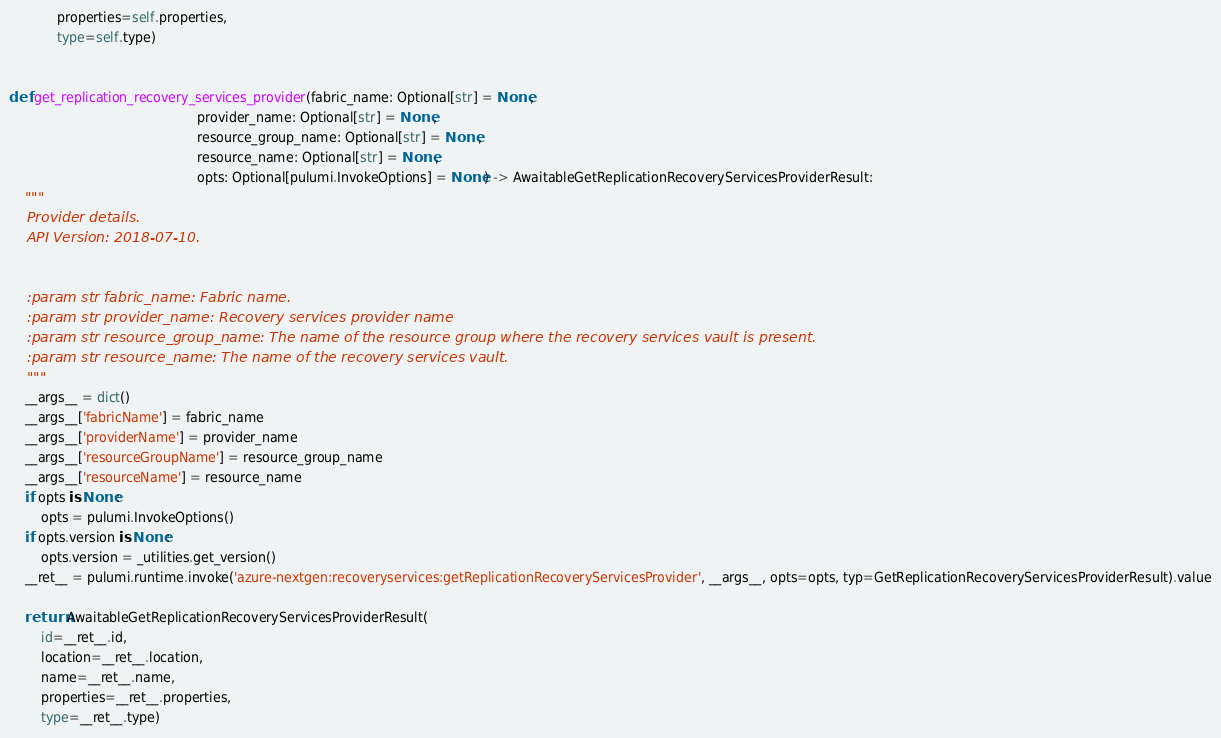Convert code to text. <code><loc_0><loc_0><loc_500><loc_500><_Python_>            properties=self.properties,
            type=self.type)


def get_replication_recovery_services_provider(fabric_name: Optional[str] = None,
                                               provider_name: Optional[str] = None,
                                               resource_group_name: Optional[str] = None,
                                               resource_name: Optional[str] = None,
                                               opts: Optional[pulumi.InvokeOptions] = None) -> AwaitableGetReplicationRecoveryServicesProviderResult:
    """
    Provider details.
    API Version: 2018-07-10.


    :param str fabric_name: Fabric name.
    :param str provider_name: Recovery services provider name
    :param str resource_group_name: The name of the resource group where the recovery services vault is present.
    :param str resource_name: The name of the recovery services vault.
    """
    __args__ = dict()
    __args__['fabricName'] = fabric_name
    __args__['providerName'] = provider_name
    __args__['resourceGroupName'] = resource_group_name
    __args__['resourceName'] = resource_name
    if opts is None:
        opts = pulumi.InvokeOptions()
    if opts.version is None:
        opts.version = _utilities.get_version()
    __ret__ = pulumi.runtime.invoke('azure-nextgen:recoveryservices:getReplicationRecoveryServicesProvider', __args__, opts=opts, typ=GetReplicationRecoveryServicesProviderResult).value

    return AwaitableGetReplicationRecoveryServicesProviderResult(
        id=__ret__.id,
        location=__ret__.location,
        name=__ret__.name,
        properties=__ret__.properties,
        type=__ret__.type)
</code> 